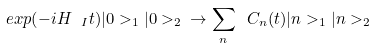Convert formula to latex. <formula><loc_0><loc_0><loc_500><loc_500>e x p ( - i H \ _ { I } t ) | 0 > _ { 1 } | 0 > _ { 2 } \ \rightarrow \sum _ { n } \ C _ { n } ( t ) | n > _ { 1 } | n > _ { 2 }</formula> 